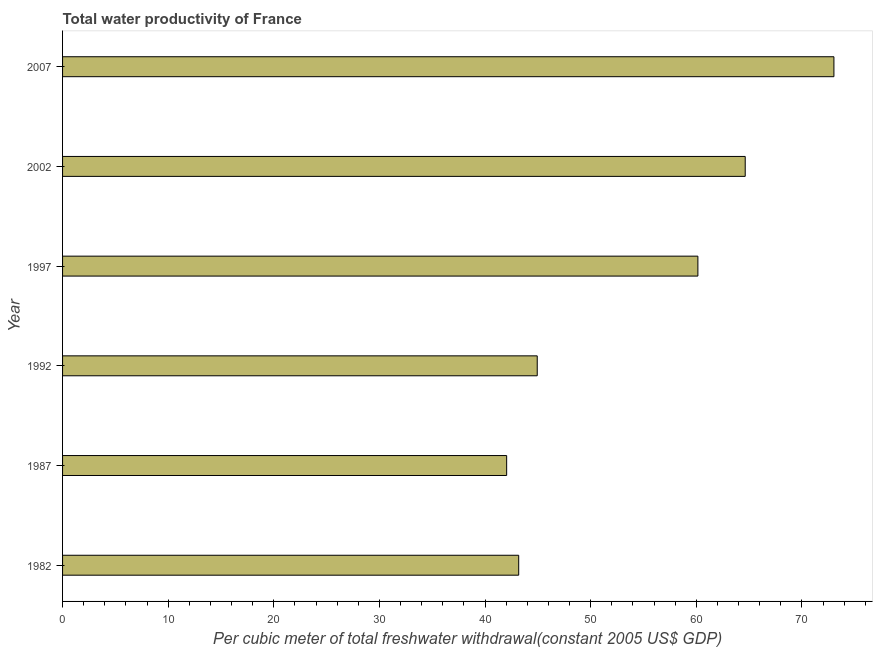Does the graph contain grids?
Offer a terse response. No. What is the title of the graph?
Offer a very short reply. Total water productivity of France. What is the label or title of the X-axis?
Ensure brevity in your answer.  Per cubic meter of total freshwater withdrawal(constant 2005 US$ GDP). What is the total water productivity in 1992?
Your answer should be very brief. 44.94. Across all years, what is the maximum total water productivity?
Give a very brief answer. 73.03. Across all years, what is the minimum total water productivity?
Give a very brief answer. 42.05. In which year was the total water productivity maximum?
Your answer should be compact. 2007. In which year was the total water productivity minimum?
Your response must be concise. 1987. What is the sum of the total water productivity?
Ensure brevity in your answer.  328. What is the difference between the total water productivity in 2002 and 2007?
Your answer should be compact. -8.4. What is the average total water productivity per year?
Provide a succinct answer. 54.67. What is the median total water productivity?
Provide a succinct answer. 52.55. In how many years, is the total water productivity greater than 60 US$?
Your answer should be very brief. 3. What is the ratio of the total water productivity in 2002 to that in 2007?
Your response must be concise. 0.89. Is the total water productivity in 1982 less than that in 1987?
Give a very brief answer. No. What is the difference between the highest and the second highest total water productivity?
Your answer should be compact. 8.4. What is the difference between the highest and the lowest total water productivity?
Your answer should be very brief. 30.99. In how many years, is the total water productivity greater than the average total water productivity taken over all years?
Make the answer very short. 3. How many bars are there?
Your answer should be compact. 6. Are all the bars in the graph horizontal?
Your response must be concise. Yes. Are the values on the major ticks of X-axis written in scientific E-notation?
Provide a succinct answer. No. What is the Per cubic meter of total freshwater withdrawal(constant 2005 US$ GDP) of 1982?
Ensure brevity in your answer.  43.19. What is the Per cubic meter of total freshwater withdrawal(constant 2005 US$ GDP) in 1987?
Provide a succinct answer. 42.05. What is the Per cubic meter of total freshwater withdrawal(constant 2005 US$ GDP) in 1992?
Provide a succinct answer. 44.94. What is the Per cubic meter of total freshwater withdrawal(constant 2005 US$ GDP) of 1997?
Offer a terse response. 60.15. What is the Per cubic meter of total freshwater withdrawal(constant 2005 US$ GDP) in 2002?
Provide a succinct answer. 64.63. What is the Per cubic meter of total freshwater withdrawal(constant 2005 US$ GDP) in 2007?
Your answer should be very brief. 73.03. What is the difference between the Per cubic meter of total freshwater withdrawal(constant 2005 US$ GDP) in 1982 and 1987?
Your answer should be compact. 1.14. What is the difference between the Per cubic meter of total freshwater withdrawal(constant 2005 US$ GDP) in 1982 and 1992?
Keep it short and to the point. -1.75. What is the difference between the Per cubic meter of total freshwater withdrawal(constant 2005 US$ GDP) in 1982 and 1997?
Ensure brevity in your answer.  -16.96. What is the difference between the Per cubic meter of total freshwater withdrawal(constant 2005 US$ GDP) in 1982 and 2002?
Offer a terse response. -21.45. What is the difference between the Per cubic meter of total freshwater withdrawal(constant 2005 US$ GDP) in 1982 and 2007?
Offer a very short reply. -29.84. What is the difference between the Per cubic meter of total freshwater withdrawal(constant 2005 US$ GDP) in 1987 and 1992?
Your answer should be very brief. -2.9. What is the difference between the Per cubic meter of total freshwater withdrawal(constant 2005 US$ GDP) in 1987 and 1997?
Offer a terse response. -18.11. What is the difference between the Per cubic meter of total freshwater withdrawal(constant 2005 US$ GDP) in 1987 and 2002?
Keep it short and to the point. -22.59. What is the difference between the Per cubic meter of total freshwater withdrawal(constant 2005 US$ GDP) in 1987 and 2007?
Ensure brevity in your answer.  -30.99. What is the difference between the Per cubic meter of total freshwater withdrawal(constant 2005 US$ GDP) in 1992 and 1997?
Provide a succinct answer. -15.21. What is the difference between the Per cubic meter of total freshwater withdrawal(constant 2005 US$ GDP) in 1992 and 2002?
Give a very brief answer. -19.69. What is the difference between the Per cubic meter of total freshwater withdrawal(constant 2005 US$ GDP) in 1992 and 2007?
Your answer should be very brief. -28.09. What is the difference between the Per cubic meter of total freshwater withdrawal(constant 2005 US$ GDP) in 1997 and 2002?
Your response must be concise. -4.48. What is the difference between the Per cubic meter of total freshwater withdrawal(constant 2005 US$ GDP) in 1997 and 2007?
Offer a very short reply. -12.88. What is the difference between the Per cubic meter of total freshwater withdrawal(constant 2005 US$ GDP) in 2002 and 2007?
Your answer should be very brief. -8.4. What is the ratio of the Per cubic meter of total freshwater withdrawal(constant 2005 US$ GDP) in 1982 to that in 1992?
Provide a succinct answer. 0.96. What is the ratio of the Per cubic meter of total freshwater withdrawal(constant 2005 US$ GDP) in 1982 to that in 1997?
Your answer should be very brief. 0.72. What is the ratio of the Per cubic meter of total freshwater withdrawal(constant 2005 US$ GDP) in 1982 to that in 2002?
Give a very brief answer. 0.67. What is the ratio of the Per cubic meter of total freshwater withdrawal(constant 2005 US$ GDP) in 1982 to that in 2007?
Ensure brevity in your answer.  0.59. What is the ratio of the Per cubic meter of total freshwater withdrawal(constant 2005 US$ GDP) in 1987 to that in 1992?
Your response must be concise. 0.94. What is the ratio of the Per cubic meter of total freshwater withdrawal(constant 2005 US$ GDP) in 1987 to that in 1997?
Provide a short and direct response. 0.7. What is the ratio of the Per cubic meter of total freshwater withdrawal(constant 2005 US$ GDP) in 1987 to that in 2002?
Your response must be concise. 0.65. What is the ratio of the Per cubic meter of total freshwater withdrawal(constant 2005 US$ GDP) in 1987 to that in 2007?
Provide a short and direct response. 0.58. What is the ratio of the Per cubic meter of total freshwater withdrawal(constant 2005 US$ GDP) in 1992 to that in 1997?
Provide a succinct answer. 0.75. What is the ratio of the Per cubic meter of total freshwater withdrawal(constant 2005 US$ GDP) in 1992 to that in 2002?
Make the answer very short. 0.69. What is the ratio of the Per cubic meter of total freshwater withdrawal(constant 2005 US$ GDP) in 1992 to that in 2007?
Offer a terse response. 0.61. What is the ratio of the Per cubic meter of total freshwater withdrawal(constant 2005 US$ GDP) in 1997 to that in 2002?
Give a very brief answer. 0.93. What is the ratio of the Per cubic meter of total freshwater withdrawal(constant 2005 US$ GDP) in 1997 to that in 2007?
Make the answer very short. 0.82. What is the ratio of the Per cubic meter of total freshwater withdrawal(constant 2005 US$ GDP) in 2002 to that in 2007?
Your answer should be very brief. 0.89. 